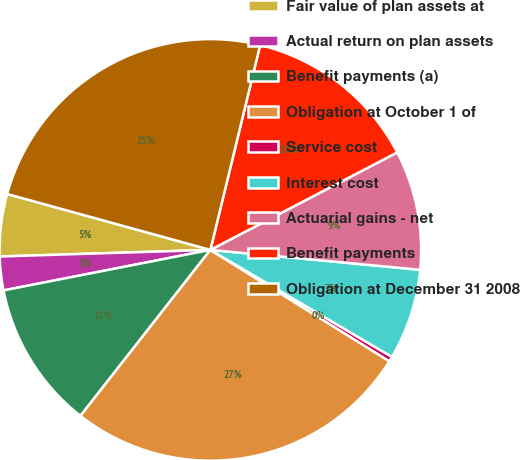Convert chart to OTSL. <chart><loc_0><loc_0><loc_500><loc_500><pie_chart><fcel>Fair value of plan assets at<fcel>Actual return on plan assets<fcel>Benefit payments (a)<fcel>Obligation at October 1 of<fcel>Service cost<fcel>Interest cost<fcel>Actuarial gains - net<fcel>Benefit payments<fcel>Obligation at December 31 2008<nl><fcel>4.77%<fcel>2.58%<fcel>11.35%<fcel>26.71%<fcel>0.38%<fcel>6.97%<fcel>9.16%<fcel>13.55%<fcel>24.52%<nl></chart> 